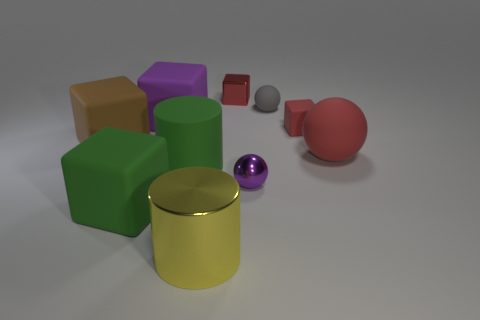There is a matte sphere that is the same size as the green cylinder; what color is it?
Offer a very short reply. Red. Are there any small purple things of the same shape as the big purple matte object?
Your answer should be compact. No. Is the number of rubber cubes less than the number of red objects?
Your answer should be very brief. No. There is a tiny object that is to the left of the purple metal object; what is its color?
Offer a terse response. Red. What is the shape of the red thing behind the small sphere that is behind the red matte block?
Offer a terse response. Cube. Is the material of the green cylinder the same as the purple object on the left side of the yellow cylinder?
Provide a succinct answer. Yes. There is a big matte object that is the same color as the tiny metallic block; what is its shape?
Keep it short and to the point. Sphere. What number of purple shiny spheres are the same size as the red shiny block?
Your answer should be compact. 1. Is the number of rubber spheres that are behind the yellow metal cylinder less than the number of big purple matte objects?
Provide a short and direct response. No. There is a tiny gray sphere; how many big green objects are to the left of it?
Offer a very short reply. 2. 